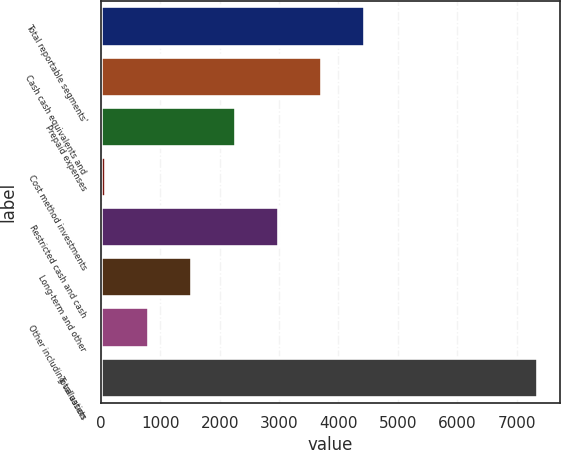Convert chart. <chart><loc_0><loc_0><loc_500><loc_500><bar_chart><fcel>Total reportable segments'<fcel>Cash cash equivalents and<fcel>Prepaid expenses<fcel>Cost method investments<fcel>Restricted cash and cash<fcel>Long-term and other<fcel>Other including valuation<fcel>Total assets<nl><fcel>4453.8<fcel>3725<fcel>2267.4<fcel>81<fcel>2996.2<fcel>1538.6<fcel>809.8<fcel>7369<nl></chart> 